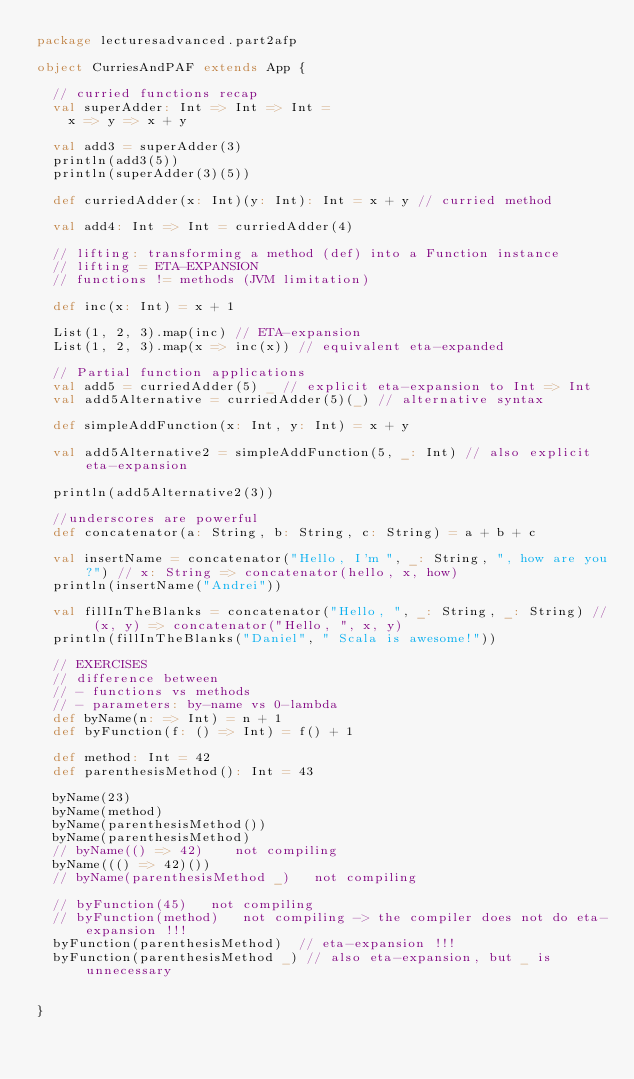Convert code to text. <code><loc_0><loc_0><loc_500><loc_500><_Scala_>package lecturesadvanced.part2afp

object CurriesAndPAF extends App {

  // curried functions recap
  val superAdder: Int => Int => Int =
    x => y => x + y

  val add3 = superAdder(3)
  println(add3(5))
  println(superAdder(3)(5))

  def curriedAdder(x: Int)(y: Int): Int = x + y // curried method

  val add4: Int => Int = curriedAdder(4)

  // lifting: transforming a method (def) into a Function instance
  // lifting = ETA-EXPANSION
  // functions != methods (JVM limitation)

  def inc(x: Int) = x + 1

  List(1, 2, 3).map(inc) // ETA-expansion
  List(1, 2, 3).map(x => inc(x)) // equivalent eta-expanded

  // Partial function applications
  val add5 = curriedAdder(5) _ // explicit eta-expansion to Int => Int
  val add5Alternative = curriedAdder(5)(_) // alternative syntax

  def simpleAddFunction(x: Int, y: Int) = x + y

  val add5Alternative2 = simpleAddFunction(5, _: Int) // also explicit eta-expansion

  println(add5Alternative2(3))

  //underscores are powerful
  def concatenator(a: String, b: String, c: String) = a + b + c

  val insertName = concatenator("Hello, I'm ", _: String, ", how are you?") // x: String => concatenator(hello, x, how)
  println(insertName("Andrei"))

  val fillInTheBlanks = concatenator("Hello, ", _: String, _: String) // (x, y) => concatenator("Hello, ", x, y)
  println(fillInTheBlanks("Daniel", " Scala is awesome!"))

  // EXERCISES
  // difference between
  // - functions vs methods
  // - parameters: by-name vs 0-lambda
  def byName(n: => Int) = n + 1
  def byFunction(f: () => Int) = f() + 1

  def method: Int = 42
  def parenthesisMethod(): Int = 43

  byName(23)
  byName(method)
  byName(parenthesisMethod())
  byName(parenthesisMethod)
  // byName(() => 42)    not compiling
  byName((() => 42)())
  // byName(parenthesisMethod _)   not compiling

  // byFunction(45)   not compiling
  // byFunction(method)   not compiling -> the compiler does not do eta-expansion !!!
  byFunction(parenthesisMethod)  // eta-expansion !!!
  byFunction(parenthesisMethod _) // also eta-expansion, but _ is unnecessary


}
</code> 